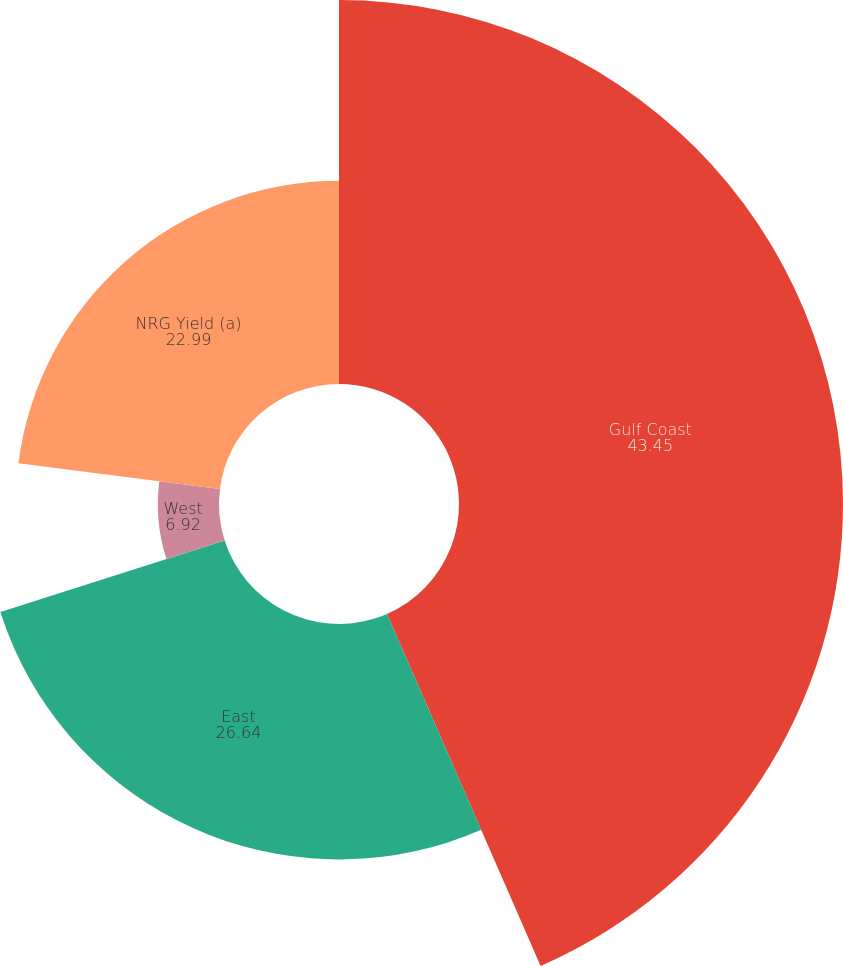<chart> <loc_0><loc_0><loc_500><loc_500><pie_chart><fcel>Gulf Coast<fcel>East<fcel>West<fcel>NRG Yield (a)<nl><fcel>43.45%<fcel>26.64%<fcel>6.92%<fcel>22.99%<nl></chart> 